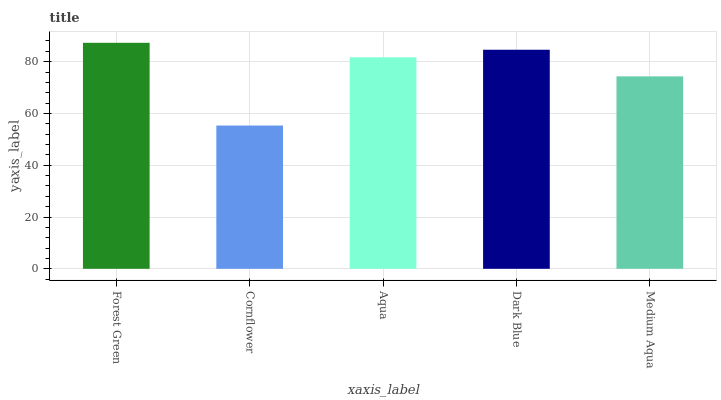Is Cornflower the minimum?
Answer yes or no. Yes. Is Forest Green the maximum?
Answer yes or no. Yes. Is Aqua the minimum?
Answer yes or no. No. Is Aqua the maximum?
Answer yes or no. No. Is Aqua greater than Cornflower?
Answer yes or no. Yes. Is Cornflower less than Aqua?
Answer yes or no. Yes. Is Cornflower greater than Aqua?
Answer yes or no. No. Is Aqua less than Cornflower?
Answer yes or no. No. Is Aqua the high median?
Answer yes or no. Yes. Is Aqua the low median?
Answer yes or no. Yes. Is Dark Blue the high median?
Answer yes or no. No. Is Dark Blue the low median?
Answer yes or no. No. 